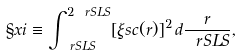Convert formula to latex. <formula><loc_0><loc_0><loc_500><loc_500>\S x i \equiv \int _ { \ r S L S } ^ { 2 \ r S L S } [ \xi s c ( r ) ] ^ { 2 } \, d \frac { r } { \ r S L S } ,</formula> 